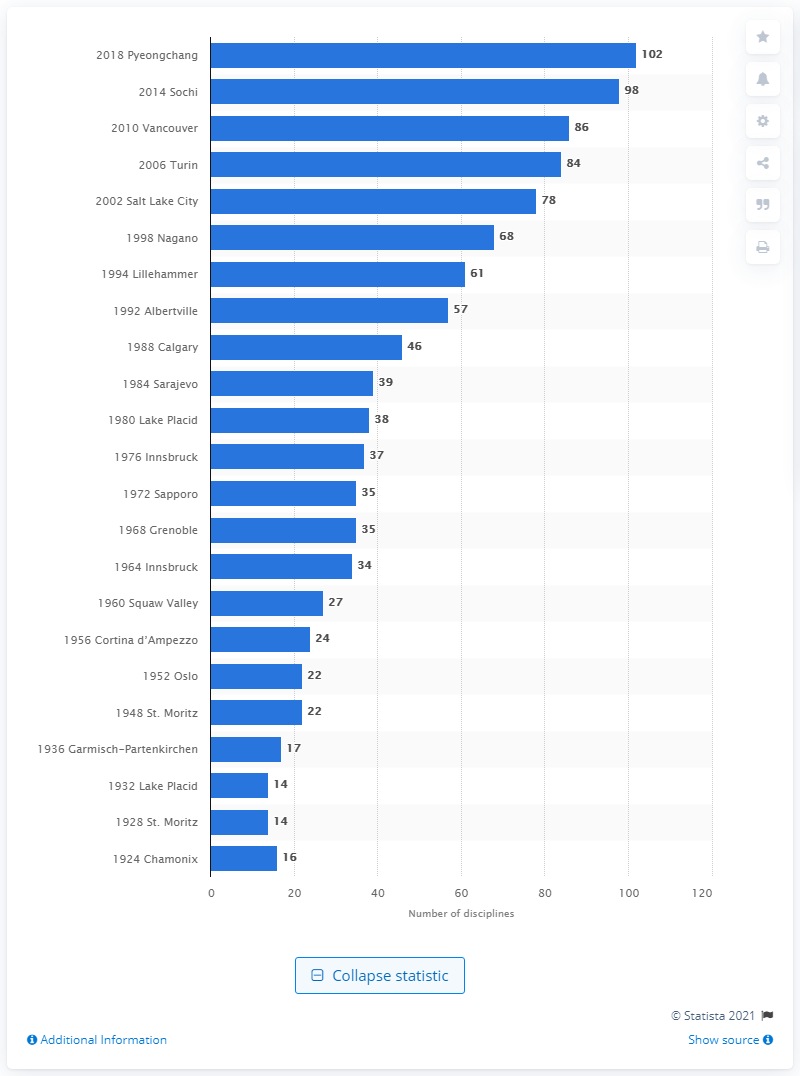Mention a couple of crucial points in this snapshot. Athletes competed in 102 events during the Winter Olympics in Pyeongchang in 2018. 